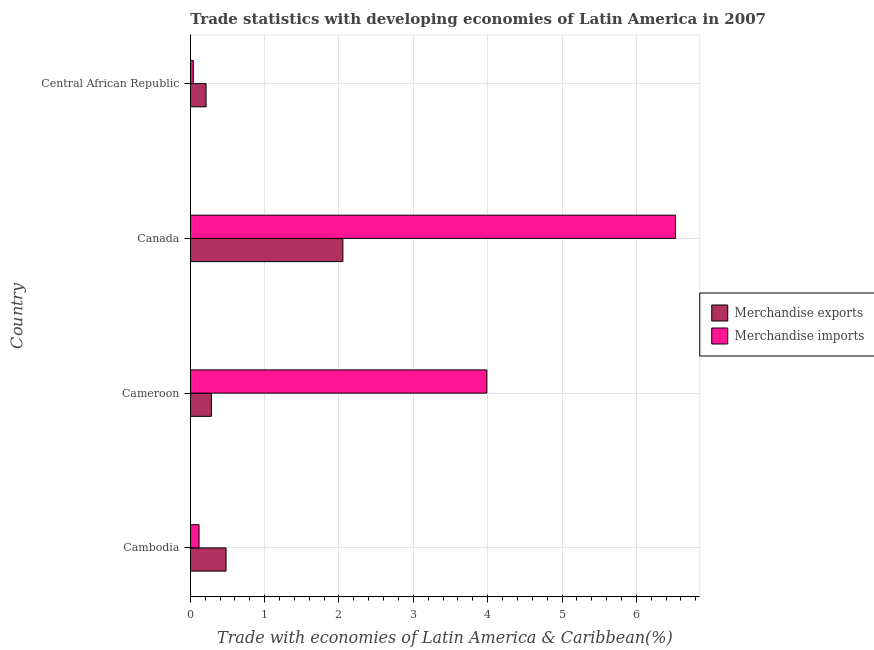How many different coloured bars are there?
Your answer should be very brief. 2. What is the label of the 3rd group of bars from the top?
Keep it short and to the point. Cameroon. In how many cases, is the number of bars for a given country not equal to the number of legend labels?
Give a very brief answer. 0. What is the merchandise imports in Central African Republic?
Make the answer very short. 0.04. Across all countries, what is the maximum merchandise exports?
Your response must be concise. 2.05. Across all countries, what is the minimum merchandise exports?
Keep it short and to the point. 0.21. In which country was the merchandise imports minimum?
Your answer should be very brief. Central African Republic. What is the total merchandise imports in the graph?
Give a very brief answer. 10.67. What is the difference between the merchandise imports in Cambodia and that in Cameroon?
Offer a terse response. -3.87. What is the difference between the merchandise exports in Canada and the merchandise imports in Cambodia?
Your answer should be compact. 1.93. What is the average merchandise exports per country?
Ensure brevity in your answer.  0.76. What is the difference between the merchandise imports and merchandise exports in Cambodia?
Offer a terse response. -0.36. What is the ratio of the merchandise imports in Cambodia to that in Cameroon?
Offer a very short reply. 0.03. Is the merchandise exports in Cameroon less than that in Central African Republic?
Offer a very short reply. No. What is the difference between the highest and the second highest merchandise imports?
Your response must be concise. 2.54. What is the difference between the highest and the lowest merchandise exports?
Offer a terse response. 1.84. In how many countries, is the merchandise exports greater than the average merchandise exports taken over all countries?
Offer a very short reply. 1. Is the sum of the merchandise exports in Cambodia and Central African Republic greater than the maximum merchandise imports across all countries?
Your answer should be very brief. No. What does the 2nd bar from the top in Cameroon represents?
Give a very brief answer. Merchandise exports. What does the 2nd bar from the bottom in Cambodia represents?
Offer a very short reply. Merchandise imports. Does the graph contain grids?
Provide a succinct answer. Yes. Where does the legend appear in the graph?
Your response must be concise. Center right. How are the legend labels stacked?
Give a very brief answer. Vertical. What is the title of the graph?
Give a very brief answer. Trade statistics with developing economies of Latin America in 2007. What is the label or title of the X-axis?
Your response must be concise. Trade with economies of Latin America & Caribbean(%). What is the Trade with economies of Latin America & Caribbean(%) of Merchandise exports in Cambodia?
Keep it short and to the point. 0.48. What is the Trade with economies of Latin America & Caribbean(%) in Merchandise imports in Cambodia?
Offer a very short reply. 0.12. What is the Trade with economies of Latin America & Caribbean(%) in Merchandise exports in Cameroon?
Provide a succinct answer. 0.28. What is the Trade with economies of Latin America & Caribbean(%) in Merchandise imports in Cameroon?
Offer a very short reply. 3.99. What is the Trade with economies of Latin America & Caribbean(%) of Merchandise exports in Canada?
Your answer should be very brief. 2.05. What is the Trade with economies of Latin America & Caribbean(%) in Merchandise imports in Canada?
Ensure brevity in your answer.  6.53. What is the Trade with economies of Latin America & Caribbean(%) in Merchandise exports in Central African Republic?
Provide a succinct answer. 0.21. What is the Trade with economies of Latin America & Caribbean(%) of Merchandise imports in Central African Republic?
Offer a terse response. 0.04. Across all countries, what is the maximum Trade with economies of Latin America & Caribbean(%) in Merchandise exports?
Your answer should be very brief. 2.05. Across all countries, what is the maximum Trade with economies of Latin America & Caribbean(%) in Merchandise imports?
Offer a terse response. 6.53. Across all countries, what is the minimum Trade with economies of Latin America & Caribbean(%) of Merchandise exports?
Make the answer very short. 0.21. Across all countries, what is the minimum Trade with economies of Latin America & Caribbean(%) of Merchandise imports?
Provide a succinct answer. 0.04. What is the total Trade with economies of Latin America & Caribbean(%) of Merchandise exports in the graph?
Offer a very short reply. 3.03. What is the total Trade with economies of Latin America & Caribbean(%) in Merchandise imports in the graph?
Provide a succinct answer. 10.67. What is the difference between the Trade with economies of Latin America & Caribbean(%) in Merchandise exports in Cambodia and that in Cameroon?
Your answer should be very brief. 0.2. What is the difference between the Trade with economies of Latin America & Caribbean(%) in Merchandise imports in Cambodia and that in Cameroon?
Your response must be concise. -3.87. What is the difference between the Trade with economies of Latin America & Caribbean(%) of Merchandise exports in Cambodia and that in Canada?
Ensure brevity in your answer.  -1.57. What is the difference between the Trade with economies of Latin America & Caribbean(%) in Merchandise imports in Cambodia and that in Canada?
Your answer should be very brief. -6.41. What is the difference between the Trade with economies of Latin America & Caribbean(%) in Merchandise exports in Cambodia and that in Central African Republic?
Provide a succinct answer. 0.27. What is the difference between the Trade with economies of Latin America & Caribbean(%) of Merchandise imports in Cambodia and that in Central African Republic?
Your answer should be very brief. 0.08. What is the difference between the Trade with economies of Latin America & Caribbean(%) of Merchandise exports in Cameroon and that in Canada?
Keep it short and to the point. -1.77. What is the difference between the Trade with economies of Latin America & Caribbean(%) in Merchandise imports in Cameroon and that in Canada?
Give a very brief answer. -2.54. What is the difference between the Trade with economies of Latin America & Caribbean(%) of Merchandise exports in Cameroon and that in Central African Republic?
Make the answer very short. 0.07. What is the difference between the Trade with economies of Latin America & Caribbean(%) of Merchandise imports in Cameroon and that in Central African Republic?
Your answer should be compact. 3.95. What is the difference between the Trade with economies of Latin America & Caribbean(%) of Merchandise exports in Canada and that in Central African Republic?
Give a very brief answer. 1.84. What is the difference between the Trade with economies of Latin America & Caribbean(%) of Merchandise imports in Canada and that in Central African Republic?
Your answer should be very brief. 6.49. What is the difference between the Trade with economies of Latin America & Caribbean(%) in Merchandise exports in Cambodia and the Trade with economies of Latin America & Caribbean(%) in Merchandise imports in Cameroon?
Offer a terse response. -3.51. What is the difference between the Trade with economies of Latin America & Caribbean(%) of Merchandise exports in Cambodia and the Trade with economies of Latin America & Caribbean(%) of Merchandise imports in Canada?
Keep it short and to the point. -6.04. What is the difference between the Trade with economies of Latin America & Caribbean(%) of Merchandise exports in Cambodia and the Trade with economies of Latin America & Caribbean(%) of Merchandise imports in Central African Republic?
Your response must be concise. 0.44. What is the difference between the Trade with economies of Latin America & Caribbean(%) of Merchandise exports in Cameroon and the Trade with economies of Latin America & Caribbean(%) of Merchandise imports in Canada?
Provide a short and direct response. -6.24. What is the difference between the Trade with economies of Latin America & Caribbean(%) in Merchandise exports in Cameroon and the Trade with economies of Latin America & Caribbean(%) in Merchandise imports in Central African Republic?
Ensure brevity in your answer.  0.24. What is the difference between the Trade with economies of Latin America & Caribbean(%) of Merchandise exports in Canada and the Trade with economies of Latin America & Caribbean(%) of Merchandise imports in Central African Republic?
Give a very brief answer. 2.01. What is the average Trade with economies of Latin America & Caribbean(%) in Merchandise exports per country?
Your answer should be compact. 0.76. What is the average Trade with economies of Latin America & Caribbean(%) in Merchandise imports per country?
Give a very brief answer. 2.67. What is the difference between the Trade with economies of Latin America & Caribbean(%) in Merchandise exports and Trade with economies of Latin America & Caribbean(%) in Merchandise imports in Cambodia?
Make the answer very short. 0.36. What is the difference between the Trade with economies of Latin America & Caribbean(%) in Merchandise exports and Trade with economies of Latin America & Caribbean(%) in Merchandise imports in Cameroon?
Your answer should be compact. -3.7. What is the difference between the Trade with economies of Latin America & Caribbean(%) of Merchandise exports and Trade with economies of Latin America & Caribbean(%) of Merchandise imports in Canada?
Offer a terse response. -4.47. What is the difference between the Trade with economies of Latin America & Caribbean(%) of Merchandise exports and Trade with economies of Latin America & Caribbean(%) of Merchandise imports in Central African Republic?
Your answer should be very brief. 0.17. What is the ratio of the Trade with economies of Latin America & Caribbean(%) in Merchandise exports in Cambodia to that in Cameroon?
Your response must be concise. 1.69. What is the ratio of the Trade with economies of Latin America & Caribbean(%) of Merchandise imports in Cambodia to that in Cameroon?
Ensure brevity in your answer.  0.03. What is the ratio of the Trade with economies of Latin America & Caribbean(%) in Merchandise exports in Cambodia to that in Canada?
Provide a short and direct response. 0.23. What is the ratio of the Trade with economies of Latin America & Caribbean(%) in Merchandise imports in Cambodia to that in Canada?
Ensure brevity in your answer.  0.02. What is the ratio of the Trade with economies of Latin America & Caribbean(%) in Merchandise exports in Cambodia to that in Central African Republic?
Your answer should be very brief. 2.27. What is the ratio of the Trade with economies of Latin America & Caribbean(%) of Merchandise imports in Cambodia to that in Central African Republic?
Make the answer very short. 2.94. What is the ratio of the Trade with economies of Latin America & Caribbean(%) of Merchandise exports in Cameroon to that in Canada?
Offer a terse response. 0.14. What is the ratio of the Trade with economies of Latin America & Caribbean(%) in Merchandise imports in Cameroon to that in Canada?
Give a very brief answer. 0.61. What is the ratio of the Trade with economies of Latin America & Caribbean(%) of Merchandise exports in Cameroon to that in Central African Republic?
Your answer should be compact. 1.34. What is the ratio of the Trade with economies of Latin America & Caribbean(%) in Merchandise imports in Cameroon to that in Central African Republic?
Provide a short and direct response. 99.34. What is the ratio of the Trade with economies of Latin America & Caribbean(%) in Merchandise exports in Canada to that in Central African Republic?
Offer a very short reply. 9.66. What is the ratio of the Trade with economies of Latin America & Caribbean(%) of Merchandise imports in Canada to that in Central African Republic?
Provide a succinct answer. 162.52. What is the difference between the highest and the second highest Trade with economies of Latin America & Caribbean(%) in Merchandise exports?
Provide a succinct answer. 1.57. What is the difference between the highest and the second highest Trade with economies of Latin America & Caribbean(%) of Merchandise imports?
Make the answer very short. 2.54. What is the difference between the highest and the lowest Trade with economies of Latin America & Caribbean(%) in Merchandise exports?
Provide a short and direct response. 1.84. What is the difference between the highest and the lowest Trade with economies of Latin America & Caribbean(%) in Merchandise imports?
Provide a short and direct response. 6.49. 